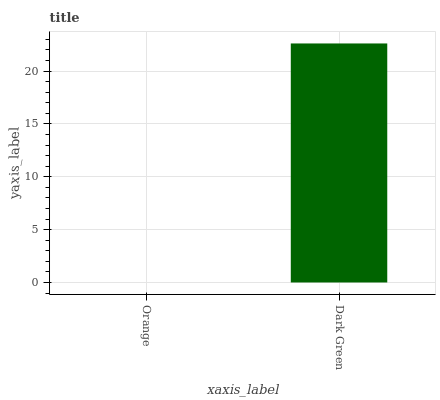Is Dark Green the minimum?
Answer yes or no. No. Is Dark Green greater than Orange?
Answer yes or no. Yes. Is Orange less than Dark Green?
Answer yes or no. Yes. Is Orange greater than Dark Green?
Answer yes or no. No. Is Dark Green less than Orange?
Answer yes or no. No. Is Dark Green the high median?
Answer yes or no. Yes. Is Orange the low median?
Answer yes or no. Yes. Is Orange the high median?
Answer yes or no. No. Is Dark Green the low median?
Answer yes or no. No. 